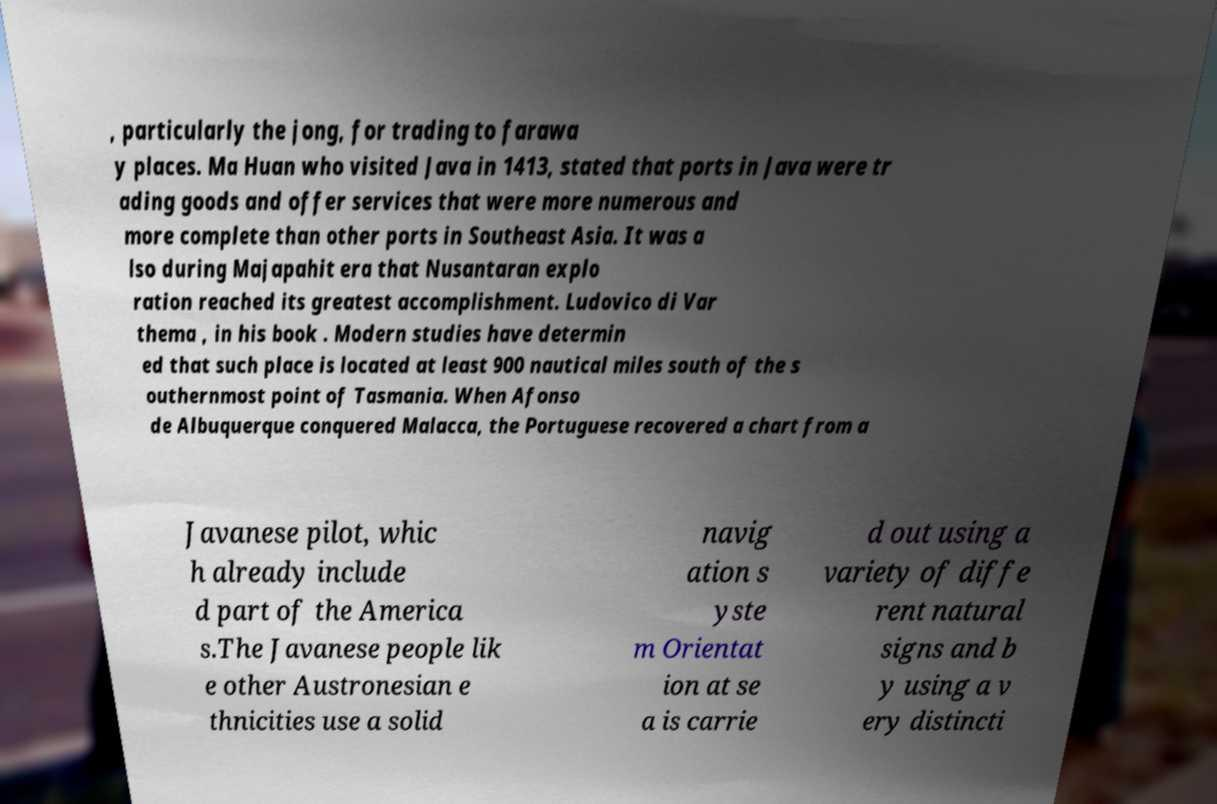For documentation purposes, I need the text within this image transcribed. Could you provide that? , particularly the jong, for trading to farawa y places. Ma Huan who visited Java in 1413, stated that ports in Java were tr ading goods and offer services that were more numerous and more complete than other ports in Southeast Asia. It was a lso during Majapahit era that Nusantaran explo ration reached its greatest accomplishment. Ludovico di Var thema , in his book . Modern studies have determin ed that such place is located at least 900 nautical miles south of the s outhernmost point of Tasmania. When Afonso de Albuquerque conquered Malacca, the Portuguese recovered a chart from a Javanese pilot, whic h already include d part of the America s.The Javanese people lik e other Austronesian e thnicities use a solid navig ation s yste m Orientat ion at se a is carrie d out using a variety of diffe rent natural signs and b y using a v ery distincti 